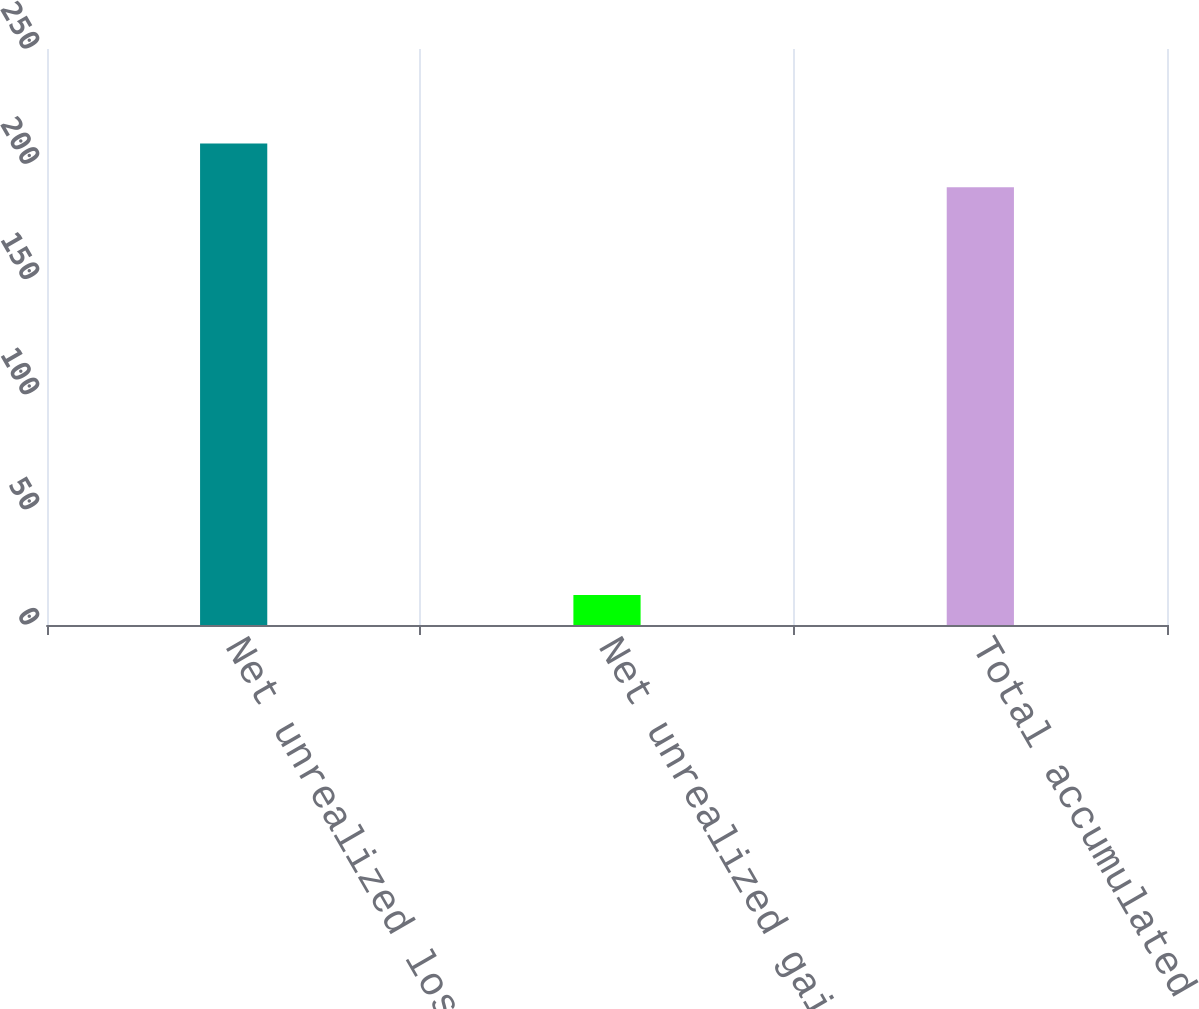<chart> <loc_0><loc_0><loc_500><loc_500><bar_chart><fcel>Net unrealized losses on<fcel>Net unrealized gains on<fcel>Total accumulated other<nl><fcel>209<fcel>13<fcel>190<nl></chart> 